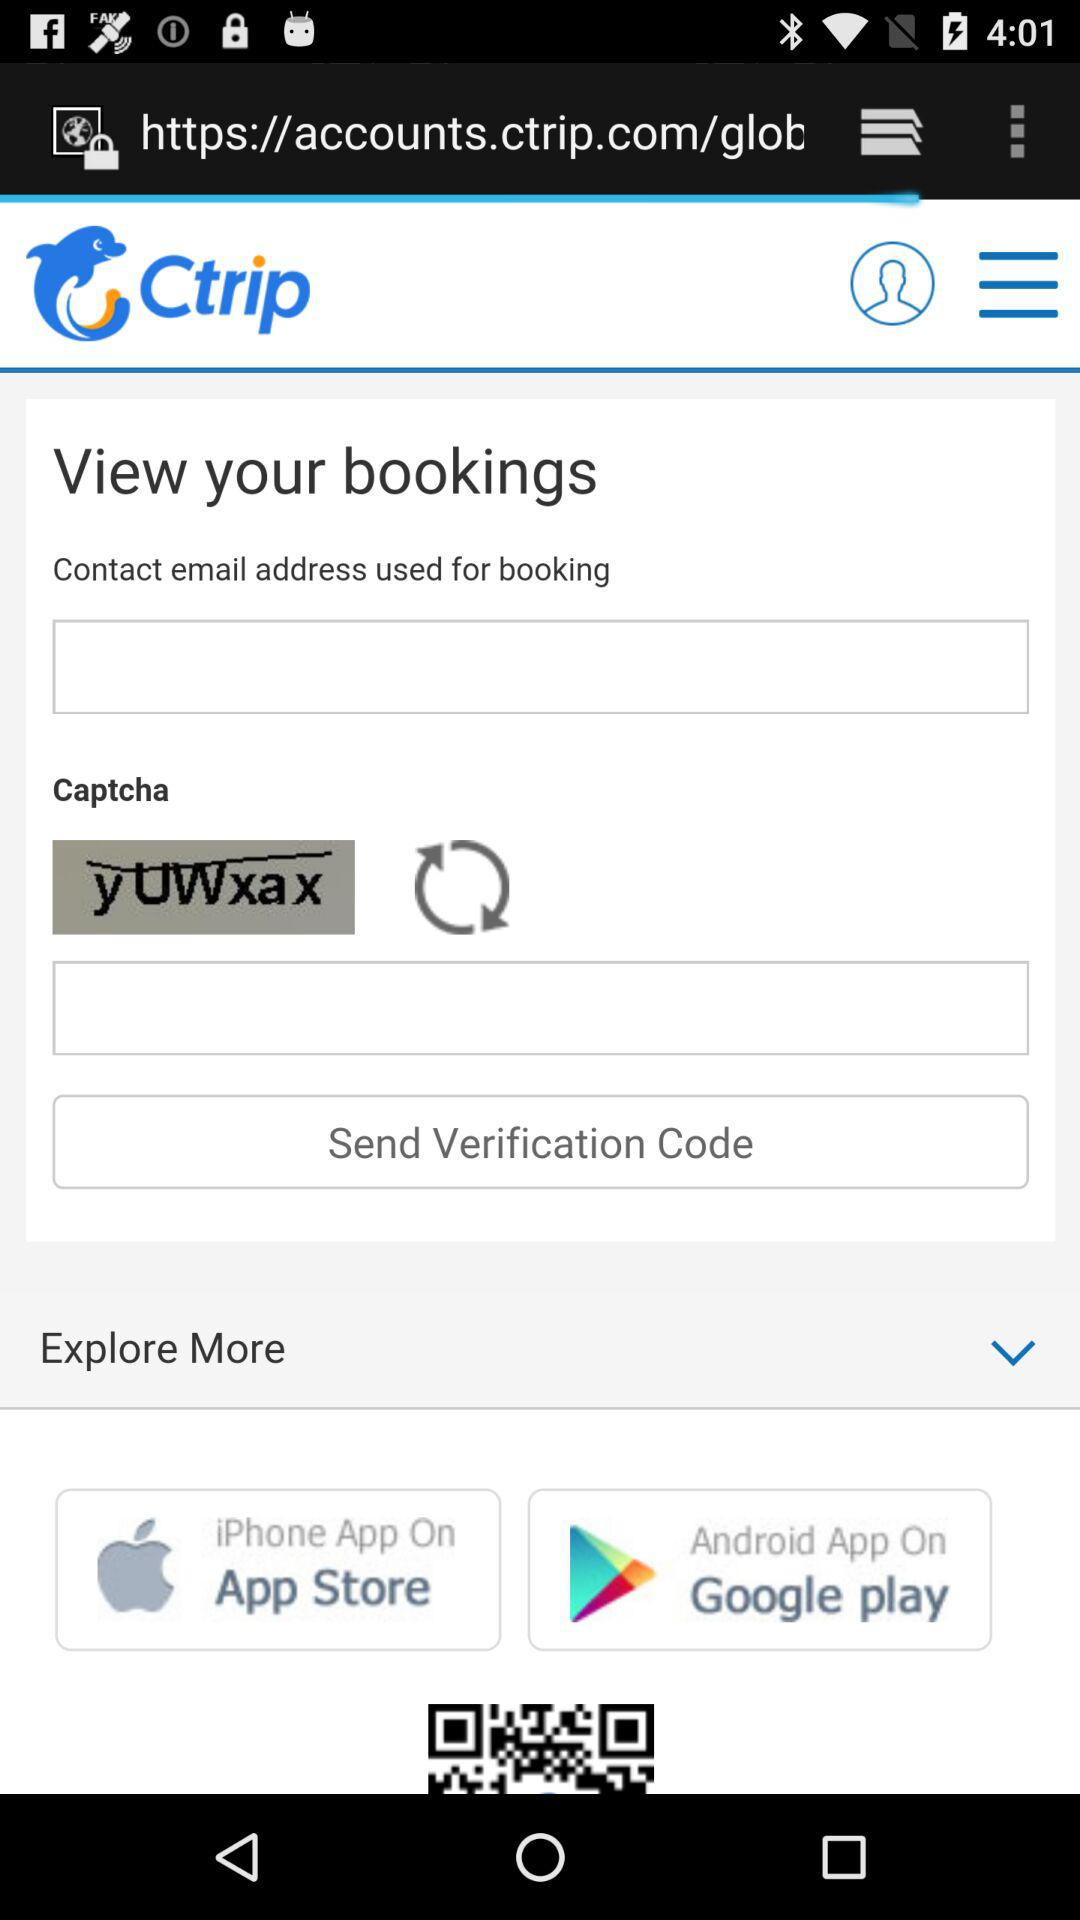What is the entered email address?
When the provided information is insufficient, respond with <no answer>. <no answer> 